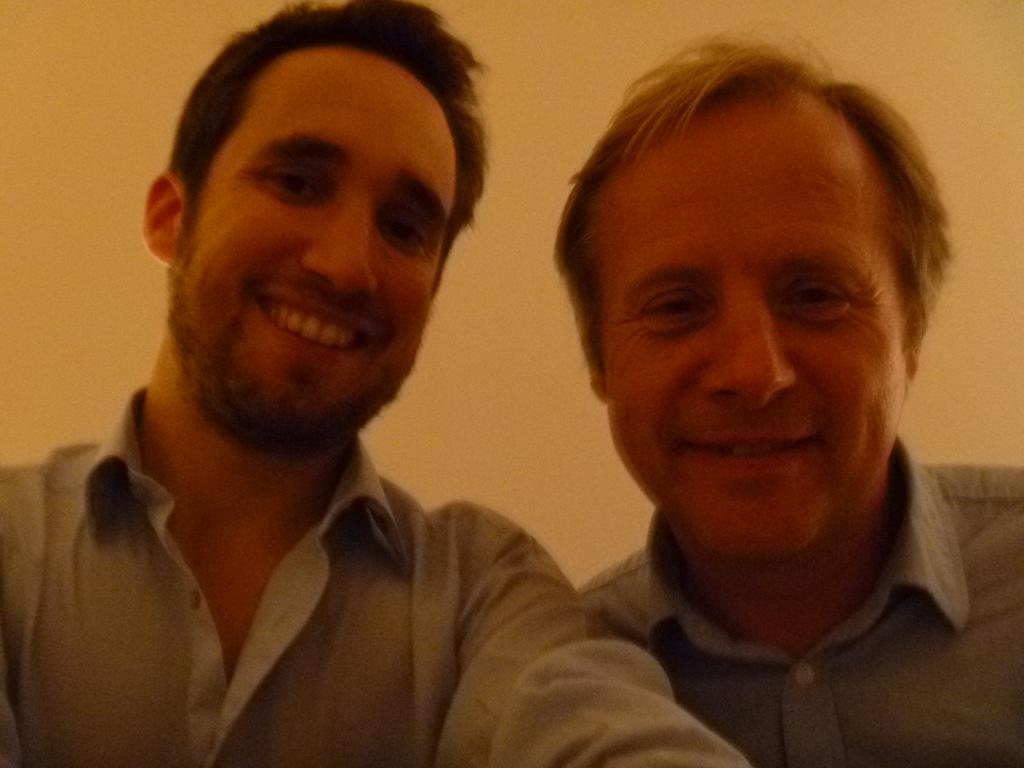How many people are in the image? There are two men in the image. What are the men doing in the image? The men are posing for the camera. What expressions do the men have in the image? The men are smiling in the image. What type of substance is the men using to enhance their smiles in the image? There is no indication in the image that the men are using any substance to enhance their smiles. 